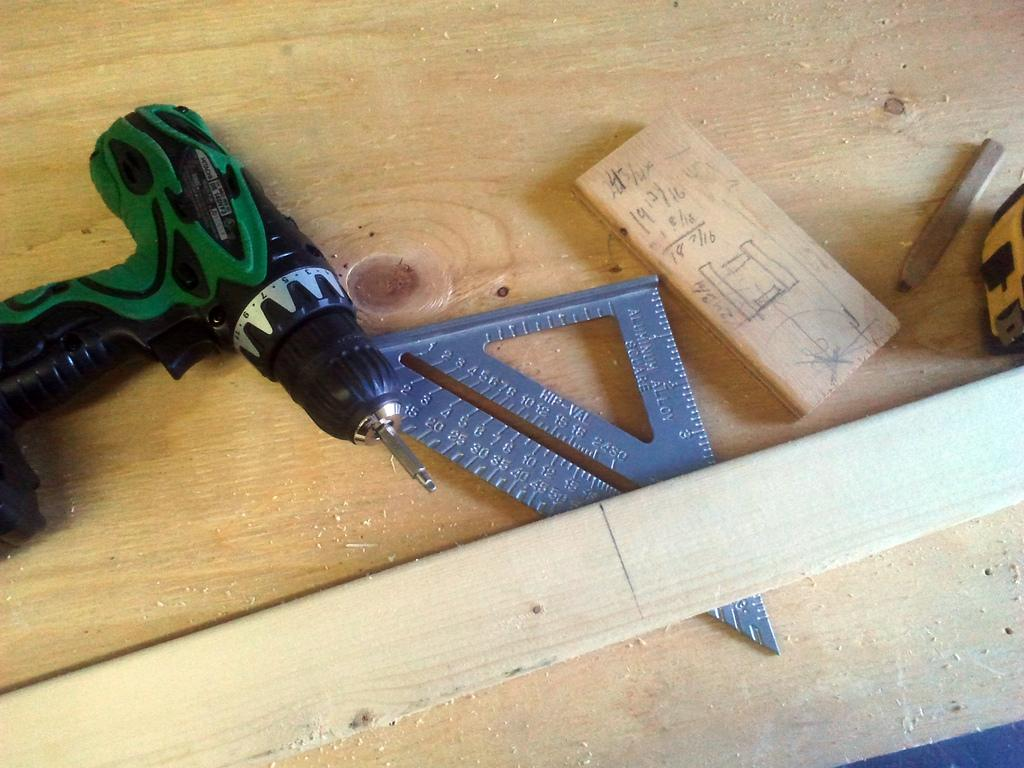Provide a one-sentence caption for the provided image. A cordless drill, other tools, and a wooden plank on a table and measurements being recorded in sixteens. 